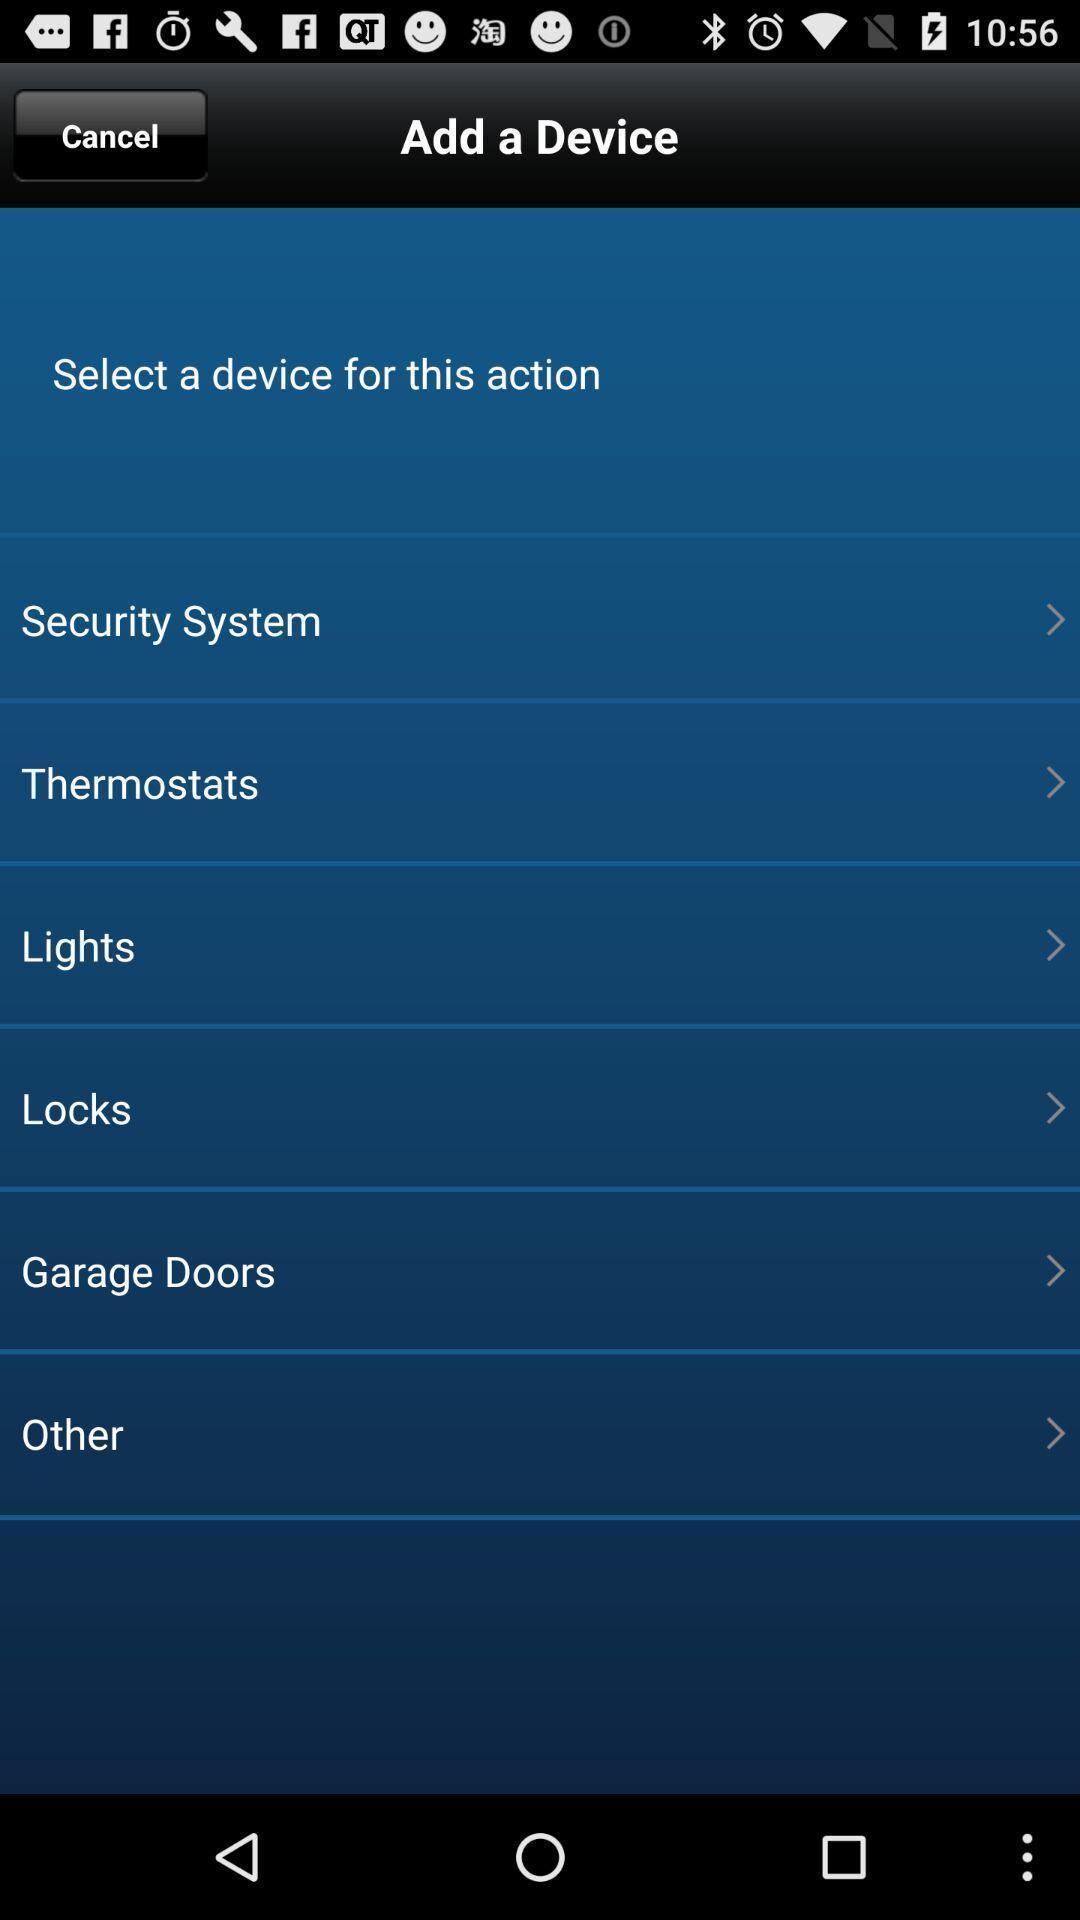Summarize the information in this screenshot. Page asking to select a device from the list. 